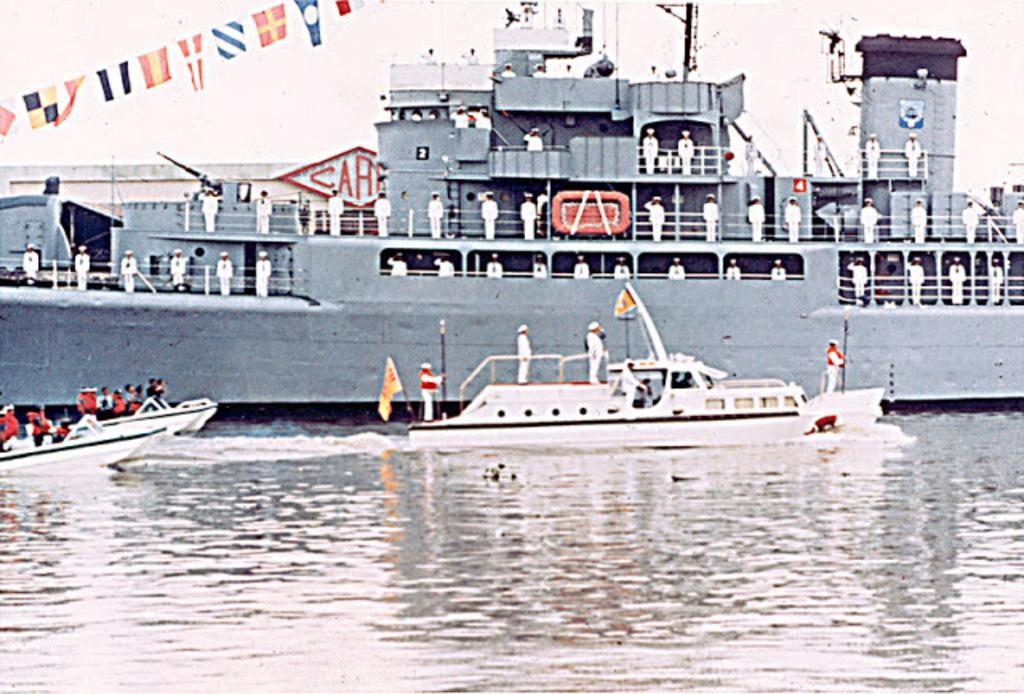What is the main element present in the image? There is water in the image. What type of boats can be seen in the water? There are white color boats in the image. What other large object is present in the water? There is a big ship in the image. What are the people on the ship wearing? The people are wearing white color dresses. What type of wax can be seen melting on the scarecrow in the image? There is no wax or scarecrow present in the image. 